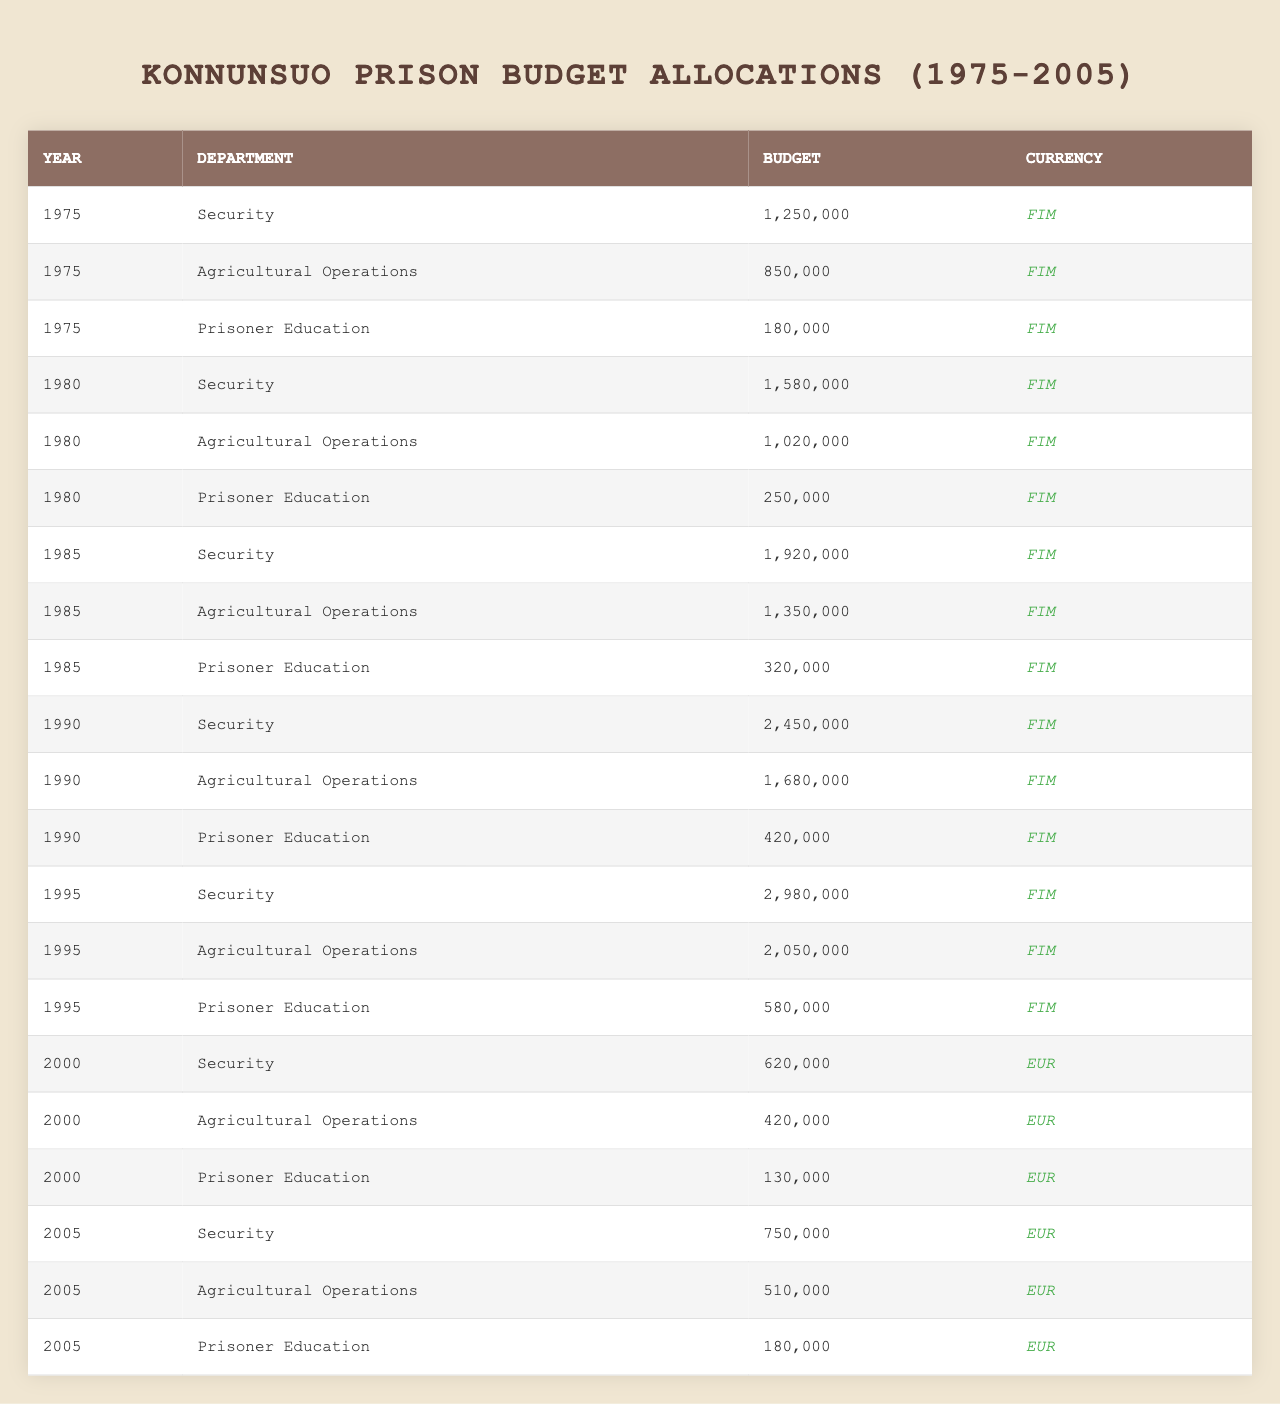What was the total budget allocated to the Security department in 1995? In 1995, the budget for the Security department was 2,980,000 FIM. This is a single data point from the table.
Answer: 2,980,000 FIM How much more was allocated to Agricultural Operations in 1990 compared to 1985? The budget for Agricultural Operations in 1990 was 1,680,000 FIM, and in 1985 it was 1,350,000 FIM. The difference is 1,680,000 - 1,350,000 = 330,000 FIM.
Answer: 330,000 FIM Did the budget for Prisoner Education increase from 1975 to 2005? In 1975, the budget for Prisoner Education was 180,000 FIM, and in 2005 it was 180,000 EUR. Since the currency changed from FIM to EUR, we cannot directly compare these amounts without converting FIM to EUR, indicating it did not increase in absolute terms.
Answer: No Which department had the highest budget in 1990, and what was the amount? In 1990, the Security department had the highest budget of 2,450,000 FIM. This can be verified by comparing the budgets of all departments for that year.
Answer: Security department, 2,450,000 FIM What was the average budget allocated to the Agricultural Operations department from 1975 to 2005? The budgets for Agricultural Operations across the years are as follows: 850,000 (1975), 1,020,000 (1980), 1,350,000 (1985), 1,680,000 (1990), 2,050,000 (1995), 420,000 (2000), 510,000 (2005). Summing these up: 850,000 + 1,020,000 + 1,350,000 + 1,680,000 + 2,050,000 + 420,000 + 510,000 = 7,510,000 FIM/EUR. There are 7 data points, so the average is 7,510,000 / 7 = 1,073,571.43 FIM/EUR
Answer: 1,073,571.43 FIM/EUR Which year had the largest increase in budget allocation for the Security department compared to the previous year? The budgets for the Security department are as follows: 1,250,000 (1975), 1,580,000 (1980), 1,920,000 (1985), 2,450,000 (1990), 2,980,000 (1995), 620,000 (2000), 750,000 (2005). The largest increase is from 1985 to 1990: 2,450,000 - 1,920,000 = 530,000. No other year had a larger increase.
Answer: 530,000 FIM Was there a decrease in the budget for Agricultural Operations from 2000 to 2005? In 2000, the budget for Agricultural Operations was 420,000 EUR, and in 2005 it was 510,000 EUR. Since the budget increased from one year to the next, the answer is yes, there was no decrease.
Answer: No How did the budget allocated to Prisoner Education change from 1985 to 1995? The budget for Prisoner Education in 1985 was 320,000 FIM, and in 1995 it was 580,000 FIM. The difference is 580,000 - 320,000 = 260,000 FIM, indicating an increase.
Answer: Increased by 260,000 FIM What was the total budget for all departments combined in 1980? In 1980, the budgets for each department were as follows: Security 1,580,000 FIM, Agricultural Operations 1,020,000 FIM, and Prisoner Education 250,000 FIM. Summing these gives: 1,580,000 + 1,020,000 + 250,000 = 2,850,000 FIM.
Answer: 2,850,000 FIM 